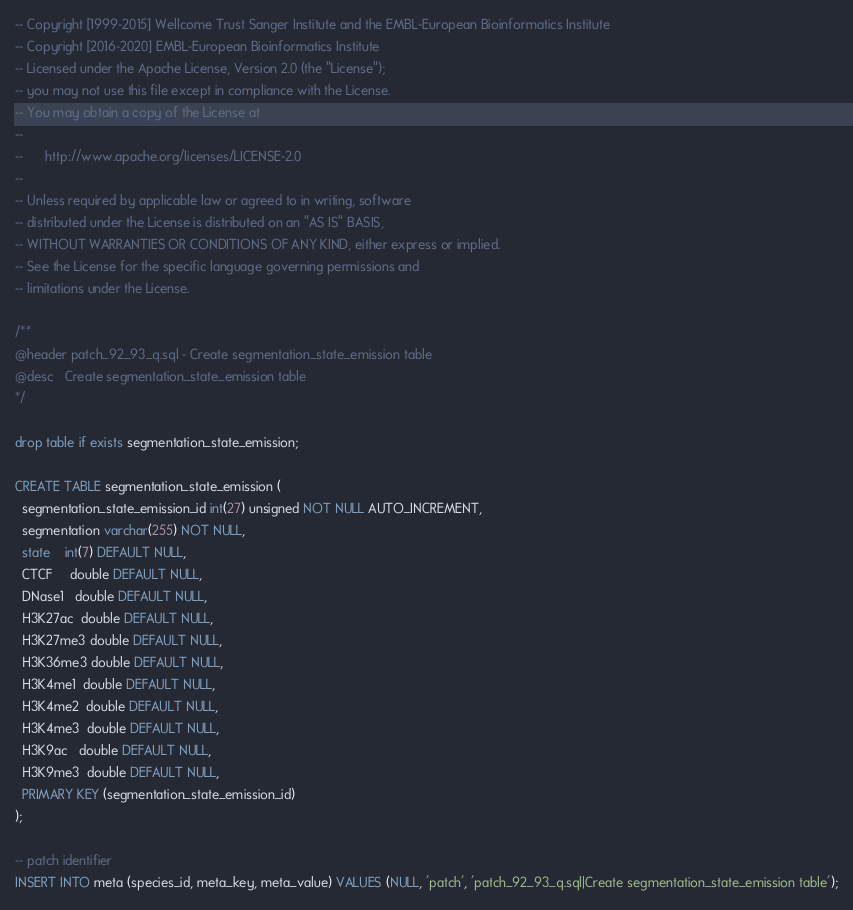<code> <loc_0><loc_0><loc_500><loc_500><_SQL_>-- Copyright [1999-2015] Wellcome Trust Sanger Institute and the EMBL-European Bioinformatics Institute
-- Copyright [2016-2020] EMBL-European Bioinformatics Institute
-- Licensed under the Apache License, Version 2.0 (the "License");
-- you may not use this file except in compliance with the License.
-- You may obtain a copy of the License at
--
--      http://www.apache.org/licenses/LICENSE-2.0
--
-- Unless required by applicable law or agreed to in writing, software
-- distributed under the License is distributed on an "AS IS" BASIS,
-- WITHOUT WARRANTIES OR CONDITIONS OF ANY KIND, either express or implied.
-- See the License for the specific language governing permissions and
-- limitations under the License.

/**
@header patch_92_93_q.sql - Create segmentation_state_emission table
@desc   Create segmentation_state_emission table
*/

drop table if exists segmentation_state_emission;

CREATE TABLE segmentation_state_emission (
  segmentation_state_emission_id int(27) unsigned NOT NULL AUTO_INCREMENT,
  segmentation varchar(255) NOT NULL,
  state    int(7) DEFAULT NULL,
  CTCF     double DEFAULT NULL,
  DNase1   double DEFAULT NULL,
  H3K27ac  double DEFAULT NULL,
  H3K27me3 double DEFAULT NULL,
  H3K36me3 double DEFAULT NULL,
  H3K4me1  double DEFAULT NULL,
  H3K4me2  double DEFAULT NULL,
  H3K4me3  double DEFAULT NULL,
  H3K9ac   double DEFAULT NULL,
  H3K9me3  double DEFAULT NULL,
  PRIMARY KEY (segmentation_state_emission_id)
);

-- patch identifier
INSERT INTO meta (species_id, meta_key, meta_value) VALUES (NULL, 'patch', 'patch_92_93_q.sql|Create segmentation_state_emission table');
</code> 